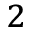<formula> <loc_0><loc_0><loc_500><loc_500>_ { 2 }</formula> 